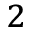<formula> <loc_0><loc_0><loc_500><loc_500>_ { 2 }</formula> 